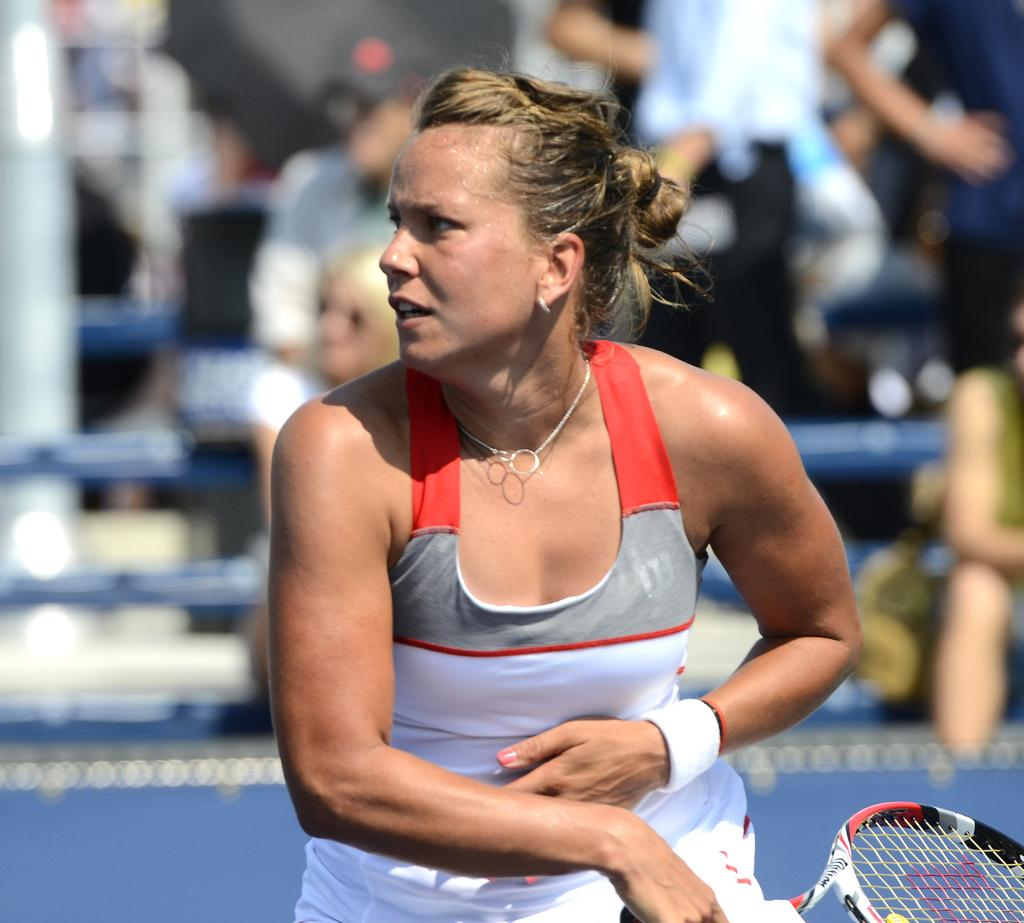Who is the main subject in the image? There is a woman standing in the center of the image. What is the woman holding in the image? The woman is holding a racket. What can be seen in the background of the image? In the background, there is a group of people standing. How many tomatoes are on the twig in the image? There are no tomatoes or twigs present in the image. 